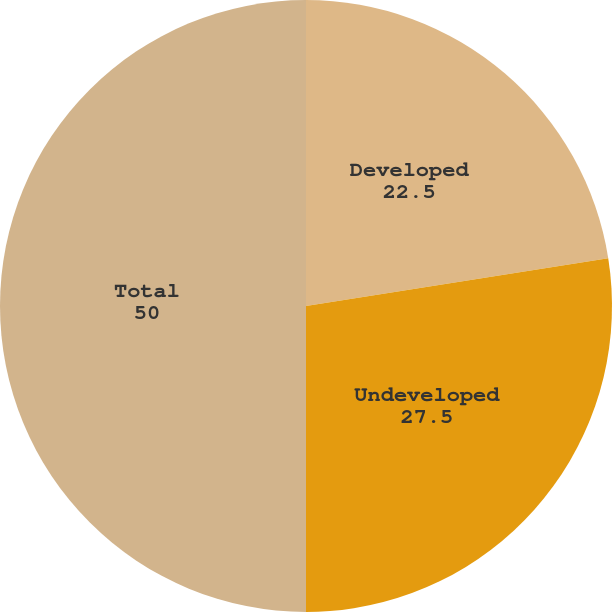Convert chart to OTSL. <chart><loc_0><loc_0><loc_500><loc_500><pie_chart><fcel>Developed<fcel>Undeveloped<fcel>Total<nl><fcel>22.5%<fcel>27.5%<fcel>50.0%<nl></chart> 